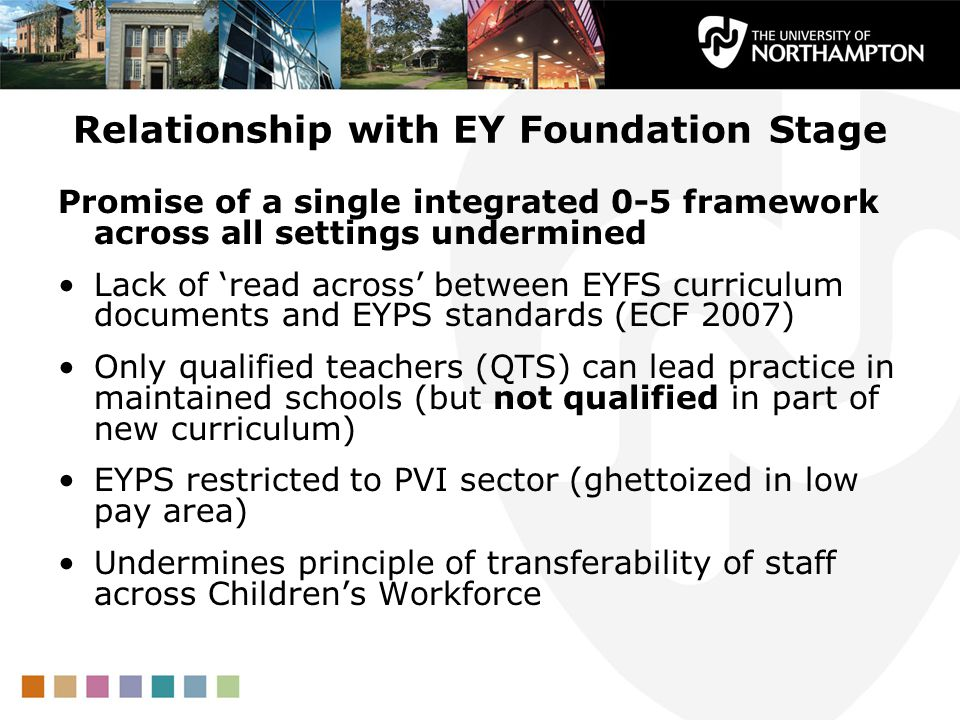How might these challenges impact the long-term development and progression of children within the EYFS framework? The challenges highlighted may have significant long-term impacts on children’s development and progression within the EYFS framework. Consistent and high-quality early years education is crucial for a child’s development. If staff mobility is hindered and the quality of education is compromised due to issues such as a lack of qualifications in parts of the curriculum and restrictions on where qualified teachers can work, children may experience inconsistency and variation in the quality of their early education. This can affect their developmental milestones and readiness for later stages of education. Continuous support and development of educators, along with a cohesive framework, are essential to mitigate these potential negative impacts. 